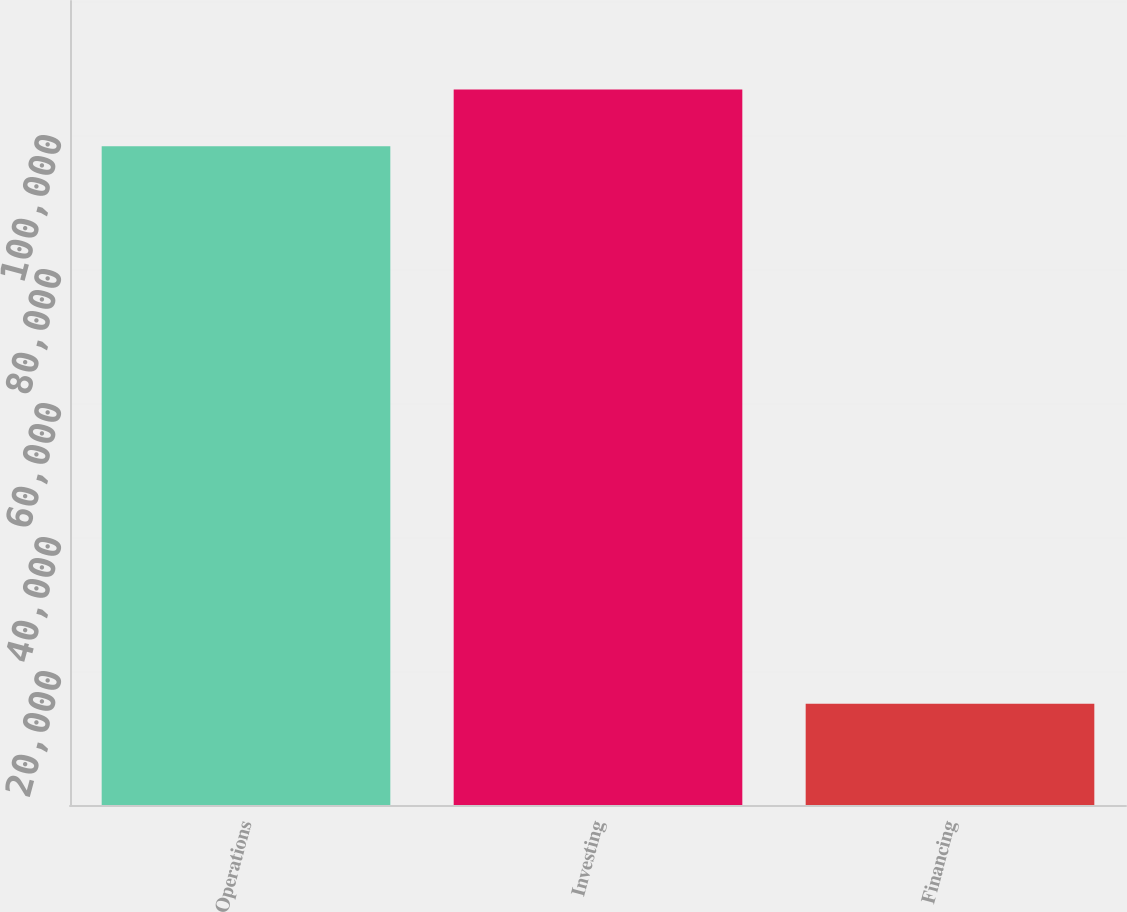Convert chart to OTSL. <chart><loc_0><loc_0><loc_500><loc_500><bar_chart><fcel>Operations<fcel>Investing<fcel>Financing<nl><fcel>98303<fcel>106781<fcel>15126<nl></chart> 